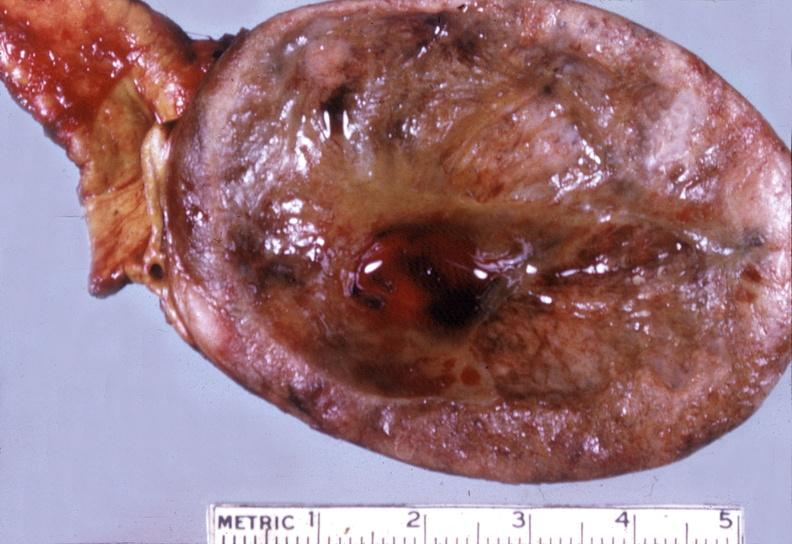does typical tuberculous exudate show adrenal, pheochromocytoma?
Answer the question using a single word or phrase. No 